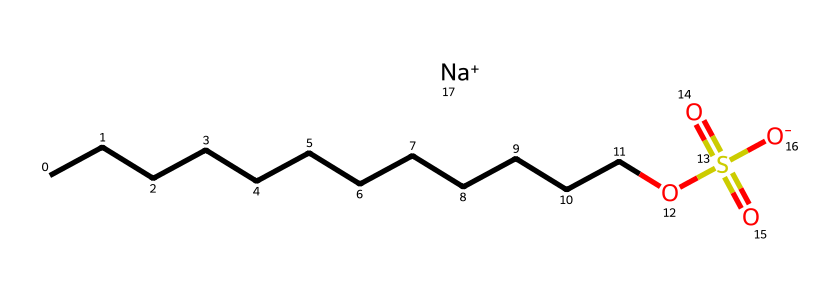how many carbon atoms are in sodium lauryl sulfate? The SMILES representation shows a continuous chain of "C" letters; counting them gives us 12 carbon atoms in the long hydrophobic tail of the structure.
Answer: 12 what is the functional group associated with sodium lauryl sulfate? The SMILES representation includes "OS(=O)(=O)[O-]", indicating the presence of a sulfate group, which is a characteristic functional group in surfactants like sodium lauryl sulfate.
Answer: sulfate group what type of chemical is sodium lauryl sulfate? The presence of a long hydrophobic carbon chain and a hydrophilic sulfate group classifies sodium lauryl sulfate as an anionic surfactant.
Answer: anionic surfactant what is the charge of the sodium ion in sodium lauryl sulfate? The notation "[Na+]" in the SMILES indicates that sodium carries a positive charge, which balances the negative charge from the sulfate group in the compound.
Answer: positive how many oxygen atoms are present in sodium lauryl sulfate? Analyzing the SMILES, we see three "O" letters as part of the sulfate group, indicating that there are three oxygen atoms in the structure.
Answer: 4 what role does the hydrophobic tail play in sodium lauryl sulfate? The long carbon chain in sodium lauryl sulfate (the hydrophobic tail) allows the molecule to interact effectively with grease and oil, enhancing its degreasing properties.
Answer: interacts with grease what is the significance of the sodium ion in sodium lauryl sulfate? The sodium ion provides solubility to sodium lauryl sulfate in water, making it effective as a surfactant and helping to stabilize the solution.
Answer: solubility 